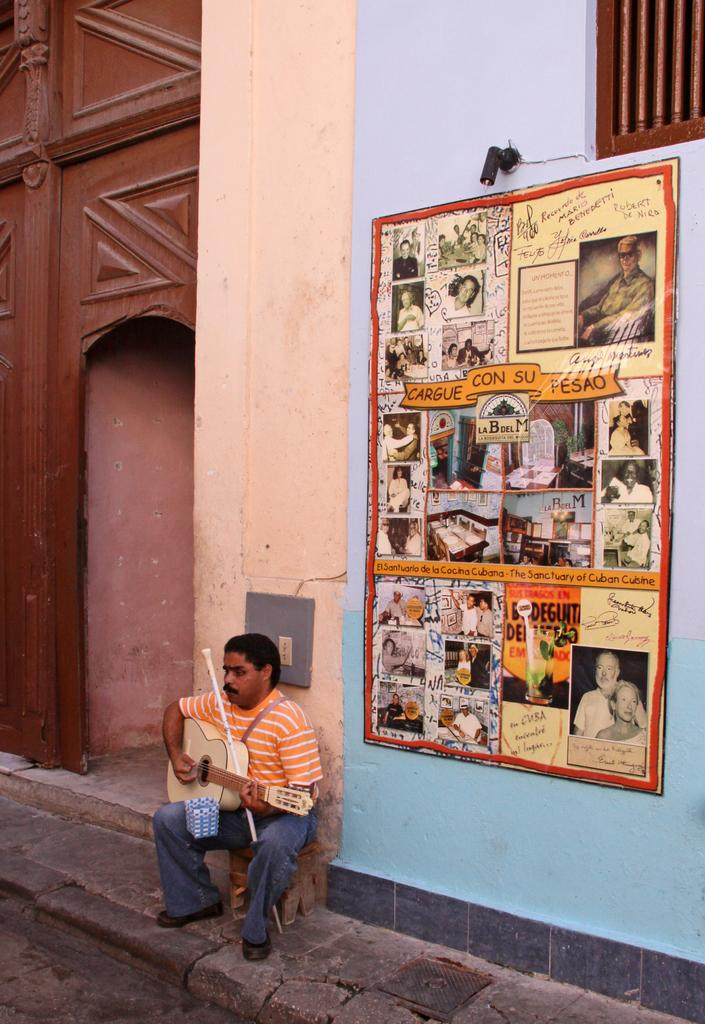What is the man in the image doing? The man is sitting in the image. What object is the man holding? The man is holding a guitar. Can you describe the artwork on the wall in the image? There is a painting on the wall in the image. What type of star can be seen in the image? There is no star visible in the image. What error is the man making in the image? There is no error being made by the man in the image; he is simply sitting and holding a guitar. 